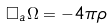<formula> <loc_0><loc_0><loc_500><loc_500>\square _ { a } \Omega = - 4 \pi \rho</formula> 